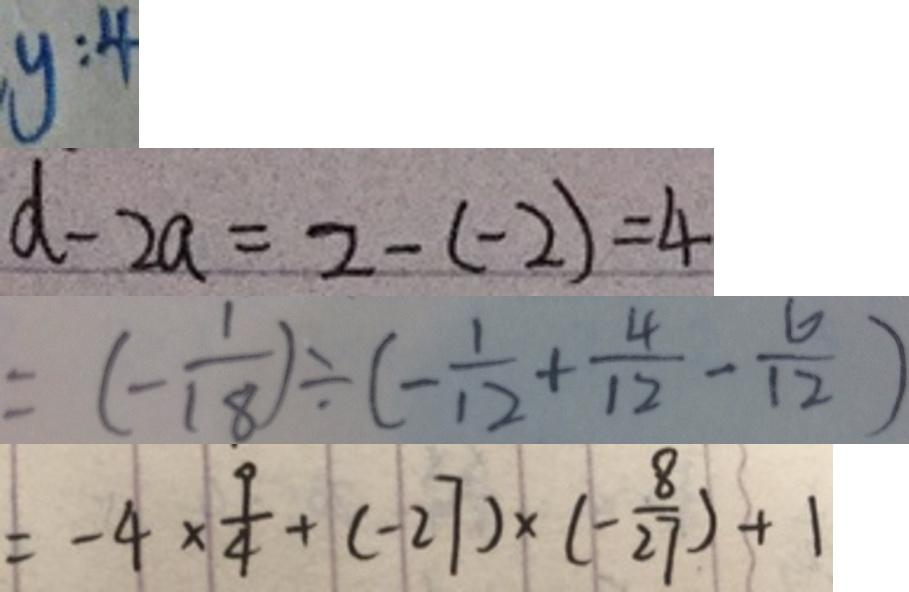Convert formula to latex. <formula><loc_0><loc_0><loc_500><loc_500>y : 4 
 d - 2 a = 2 - ( - 2 ) = 4 
 = ( - \frac { 1 } { 1 8 } ) \div ( - \frac { 1 } { 1 2 } + \frac { 4 } { 1 2 } - \frac { 6 } { 1 2 } ) 
 = - 4 \times \frac { 9 } { 4 } + ( - 2 7 ) \times ( - \frac { 8 } { 2 7 } ) + 1</formula> 